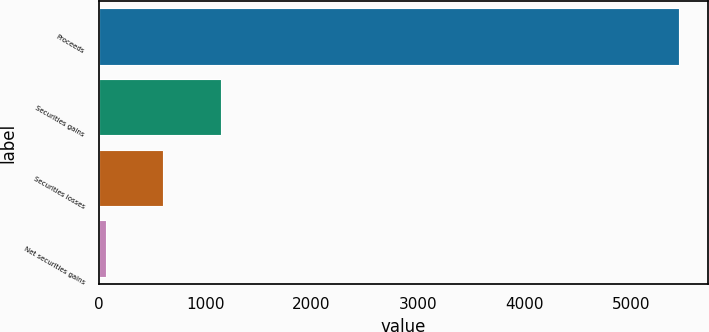Convert chart. <chart><loc_0><loc_0><loc_500><loc_500><bar_chart><fcel>Proceeds<fcel>Securities gains<fcel>Securities losses<fcel>Net securities gains<nl><fcel>5451<fcel>1145.4<fcel>607.2<fcel>69<nl></chart> 